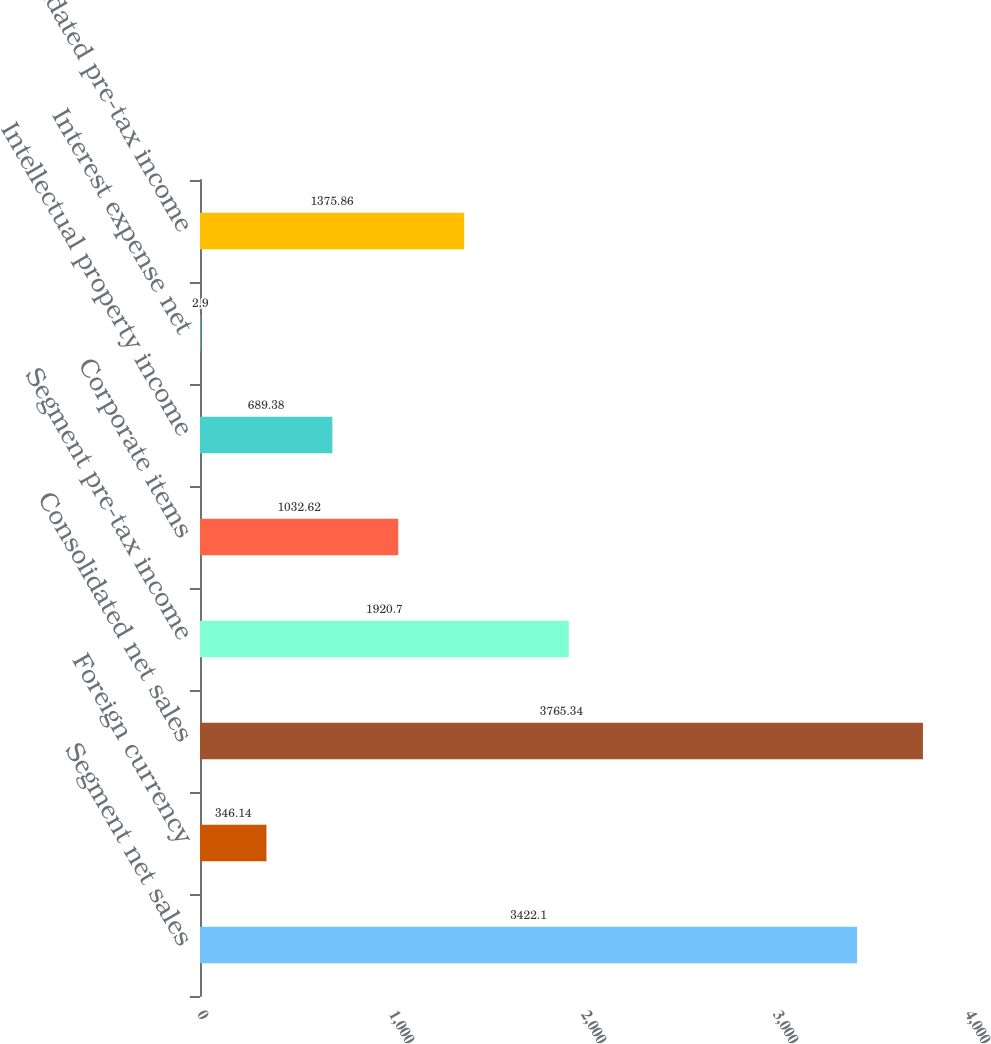Convert chart. <chart><loc_0><loc_0><loc_500><loc_500><bar_chart><fcel>Segment net sales<fcel>Foreign currency<fcel>Consolidated net sales<fcel>Segment pre-tax income<fcel>Corporate items<fcel>Intellectual property income<fcel>Interest expense net<fcel>Consolidated pre-tax income<nl><fcel>3422.1<fcel>346.14<fcel>3765.34<fcel>1920.7<fcel>1032.62<fcel>689.38<fcel>2.9<fcel>1375.86<nl></chart> 